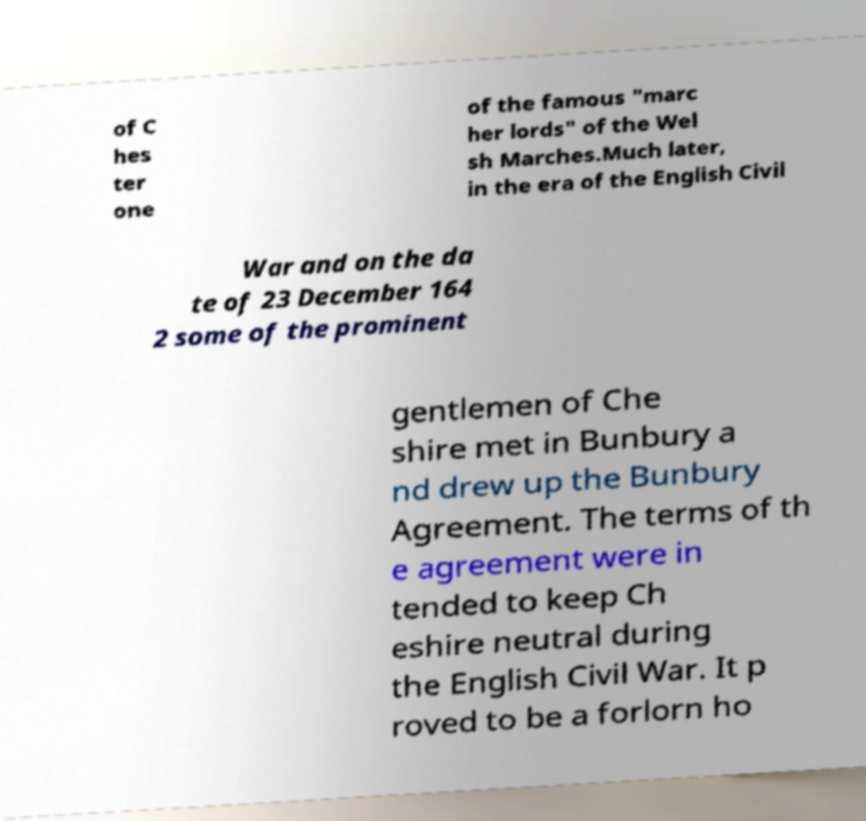What messages or text are displayed in this image? I need them in a readable, typed format. of C hes ter one of the famous "marc her lords" of the Wel sh Marches.Much later, in the era of the English Civil War and on the da te of 23 December 164 2 some of the prominent gentlemen of Che shire met in Bunbury a nd drew up the Bunbury Agreement. The terms of th e agreement were in tended to keep Ch eshire neutral during the English Civil War. It p roved to be a forlorn ho 